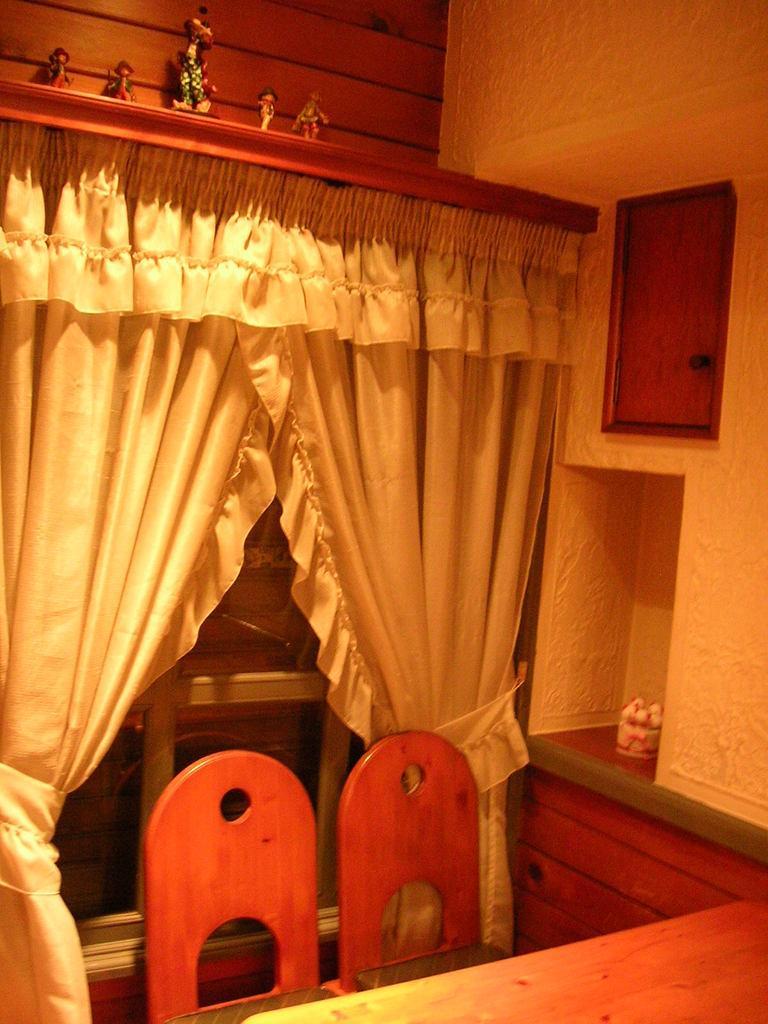Describe this image in one or two sentences. Here in this picture we can see a table and a couple of chairs present on the floor over there and behind them we can see a rack that is covered with curtains over there and we can see toys present on it over there. 